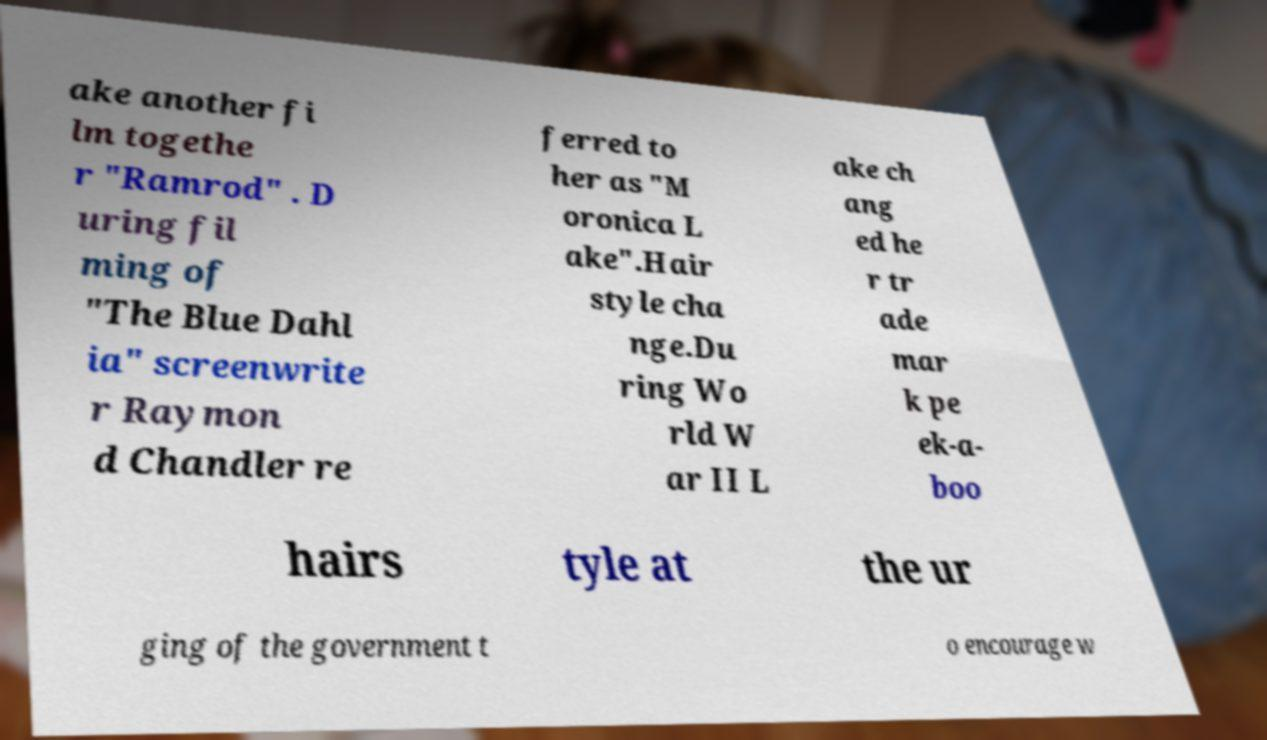I need the written content from this picture converted into text. Can you do that? ake another fi lm togethe r "Ramrod" . D uring fil ming of "The Blue Dahl ia" screenwrite r Raymon d Chandler re ferred to her as "M oronica L ake".Hair style cha nge.Du ring Wo rld W ar II L ake ch ang ed he r tr ade mar k pe ek-a- boo hairs tyle at the ur ging of the government t o encourage w 